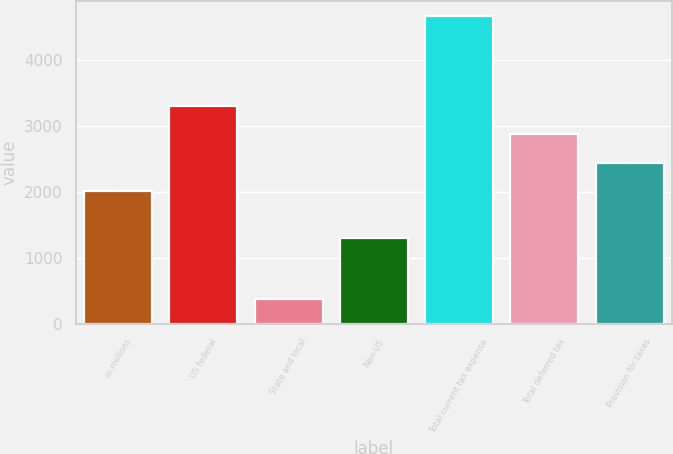<chart> <loc_0><loc_0><loc_500><loc_500><bar_chart><fcel>in millions<fcel>US federal<fcel>State and local<fcel>Non-US<fcel>Total current tax expense<fcel>Total deferred tax<fcel>Provision for taxes<nl><fcel>2018<fcel>3304.4<fcel>379<fcel>1302<fcel>4667<fcel>2875.6<fcel>2446.8<nl></chart> 